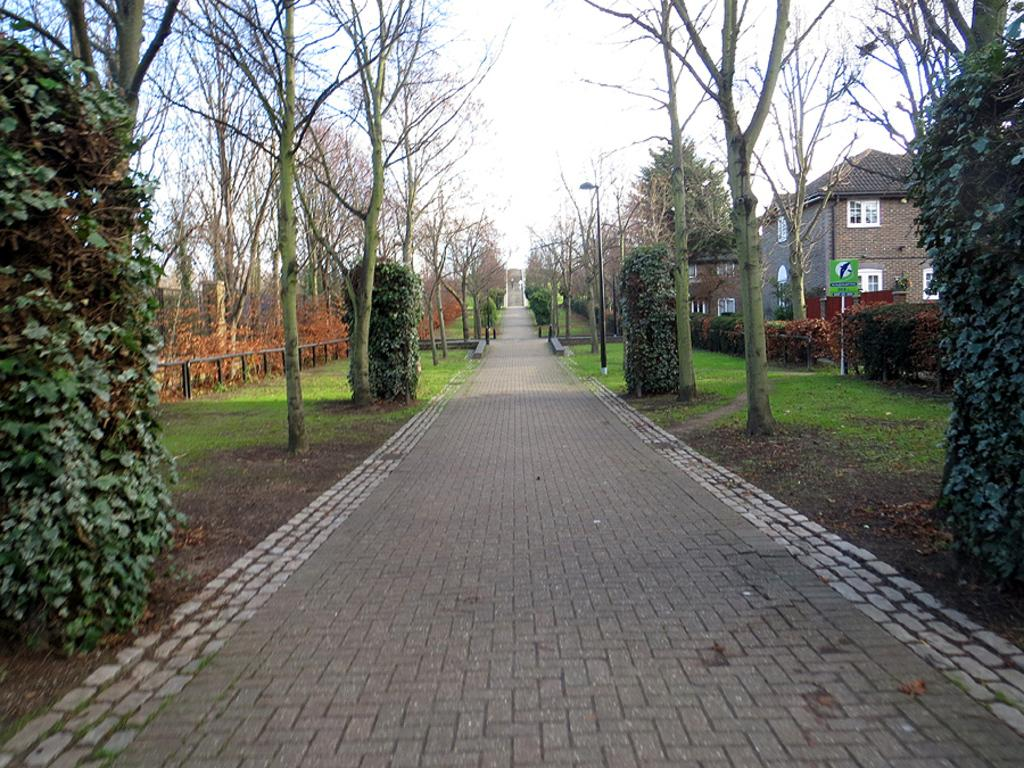What type of vegetation can be seen in the image? There are trees in the image. What type of structures are present in the image? There are houses with windows in the image. What is visible in the background of the image? The sky is visible in the image. Where is the library located in the image? There is no library present in the image. What emotion does the plant in the image display? There is no plant present in the image, and emotions cannot be attributed to plants. 